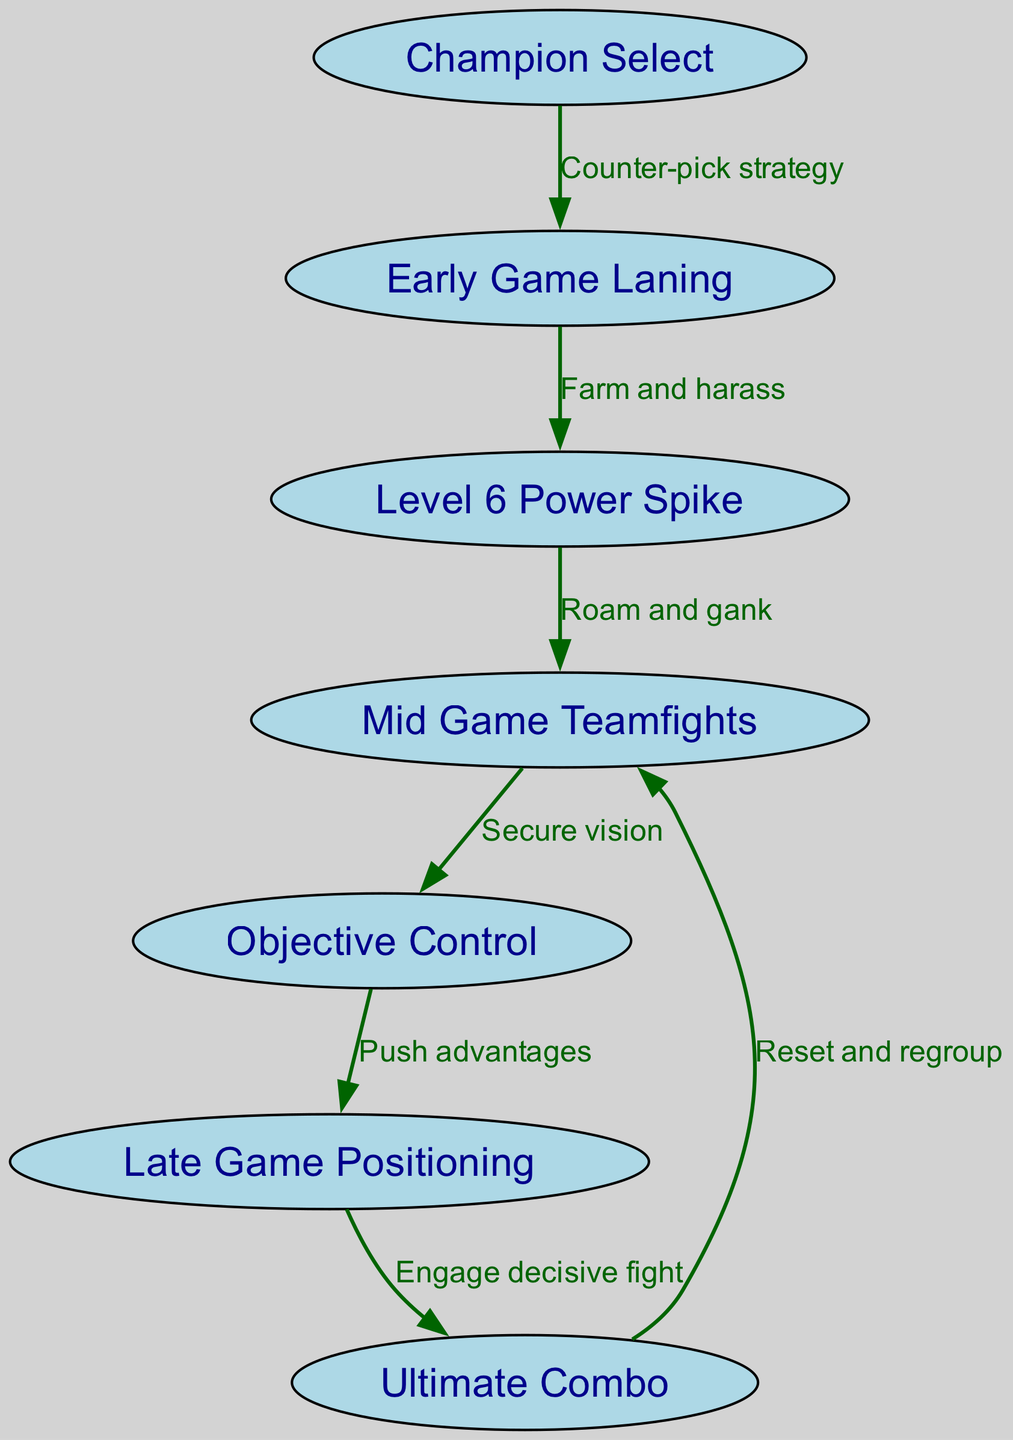What is the first step in the strategy flow? The first step in the strategy flow is represented by the node "Champion Select." This node indicates the initial phase where players select their champions for the game.
Answer: Champion Select How many nodes are in the diagram? By counting each unique node listed, we find a total of 7 nodes: Champion Select, Early Game Laning, Level 6 Power Spike, Mid Game Teamfights, Objective Control, Late Game Positioning, and Ultimate Combo.
Answer: 7 What is the relationship between "Objective Control" and "Late Game Positioning"? The edge connecting "Objective Control" to "Late Game Positioning" indicates that players should "Push advantages" after securing objectives, showing a direct strategic flow.
Answer: Push advantages What do players do during the "Level 6 Power Spike"? The relationship indicated by the edge to "Mid Game Teamfights" suggests that players will "Roam and gank" during this stage after reaching a key level of power.
Answer: Roam and gank What is the final action taken in this strategy flow? The last action in the flow is depicted by the edge leading from "Late Game Positioning" to "Ultimate Combo," which signifies the decision to "Engage decisive fight."
Answer: Engage decisive fight What is the connection from "Ultimate Combo" back to "Mid Game Teamfights"? This connection shows that after executing an ultimate combo, players should "Reset and regroup" to reposition effectively for future fights.
Answer: Reset and regroup Which node involves securing vision? The node "Mid Game Teamfights" incorporates securing vision as it is critical for executing teamfight strategies effectively.
Answer: Mid Game Teamfights What skill rotation follows "Early Game Laning"? Following "Early Game Laning," players transition to "Level 6 Power Spike" as indicated by the directed edge, emphasizing the importance of farming and harassing to reach this level.
Answer: Level 6 Power Spike What indicates a counter-pick strategy in the flow? The starting node "Champion Select" specifically highlights the importance of employing a counter-pick strategy to gain an early advantage in the game.
Answer: Counter-pick strategy 